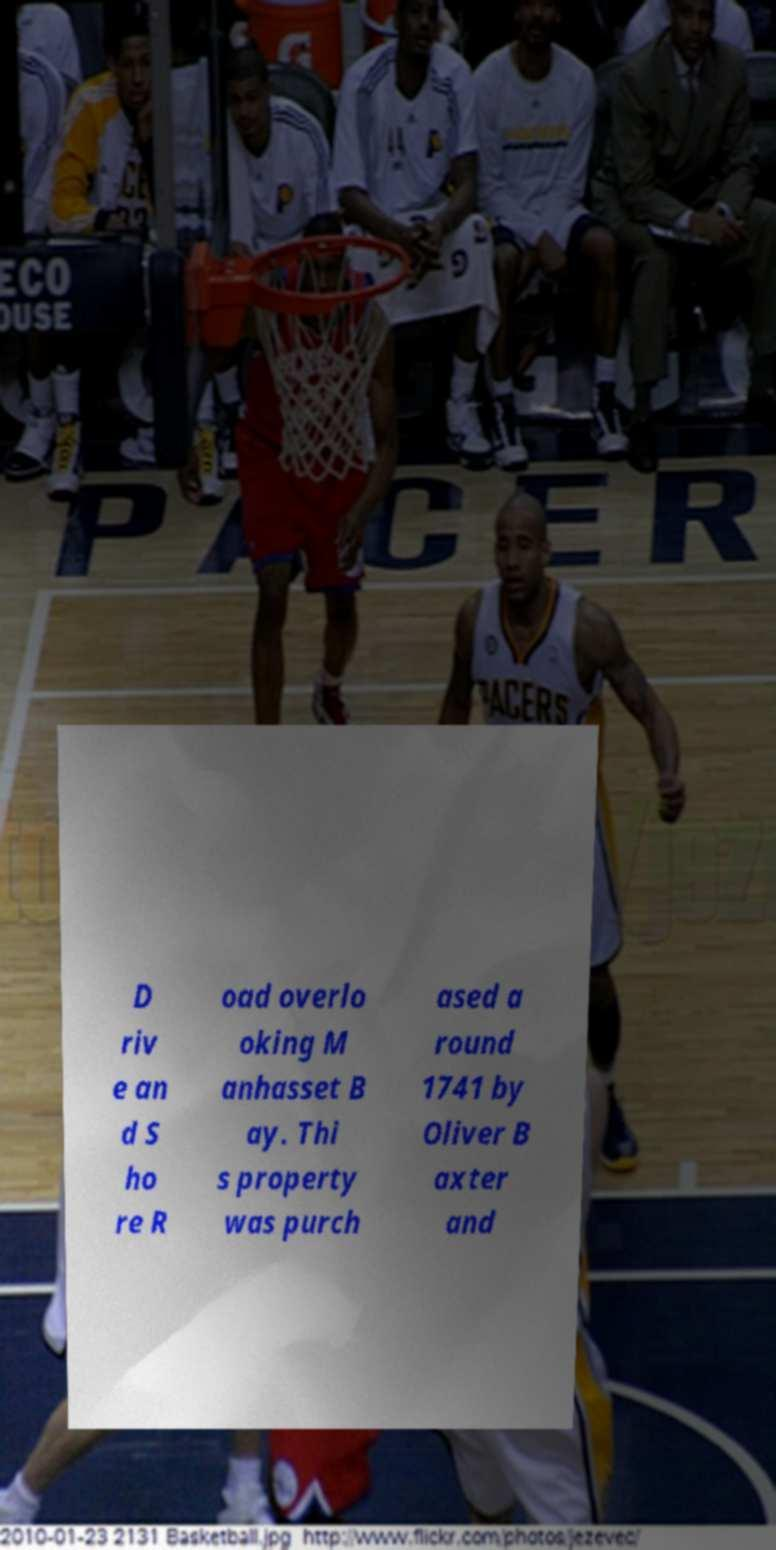I need the written content from this picture converted into text. Can you do that? D riv e an d S ho re R oad overlo oking M anhasset B ay. Thi s property was purch ased a round 1741 by Oliver B axter and 